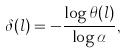Convert formula to latex. <formula><loc_0><loc_0><loc_500><loc_500>\delta ( l ) = - \frac { \log \theta ( l ) } { \log \alpha } ,</formula> 